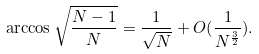Convert formula to latex. <formula><loc_0><loc_0><loc_500><loc_500>\arccos { \sqrt { \frac { N - 1 } { N } } } = \frac { 1 } { \sqrt { N } } + O ( \frac { 1 } { N ^ { \frac { 3 } { 2 } } } ) .</formula> 